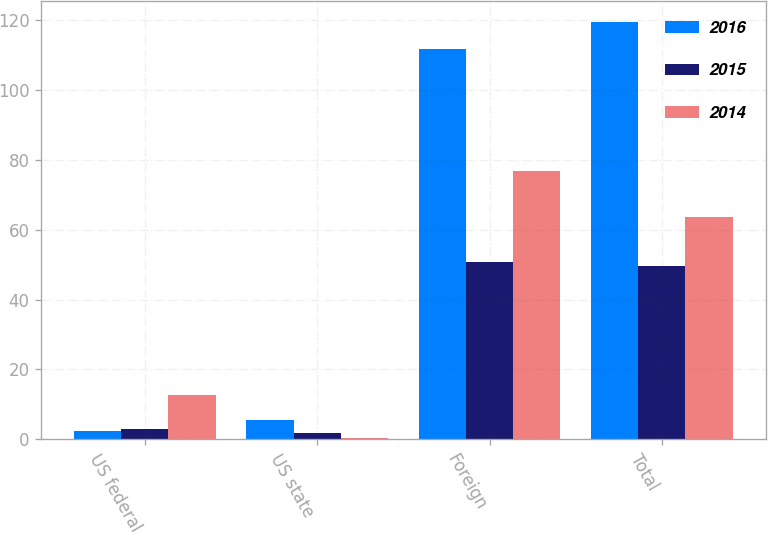Convert chart. <chart><loc_0><loc_0><loc_500><loc_500><stacked_bar_chart><ecel><fcel>US federal<fcel>US state<fcel>Foreign<fcel>Total<nl><fcel>2016<fcel>2.3<fcel>5.6<fcel>111.7<fcel>119.6<nl><fcel>2015<fcel>3<fcel>1.7<fcel>50.9<fcel>49.6<nl><fcel>2014<fcel>12.8<fcel>0.3<fcel>76.7<fcel>63.6<nl></chart> 